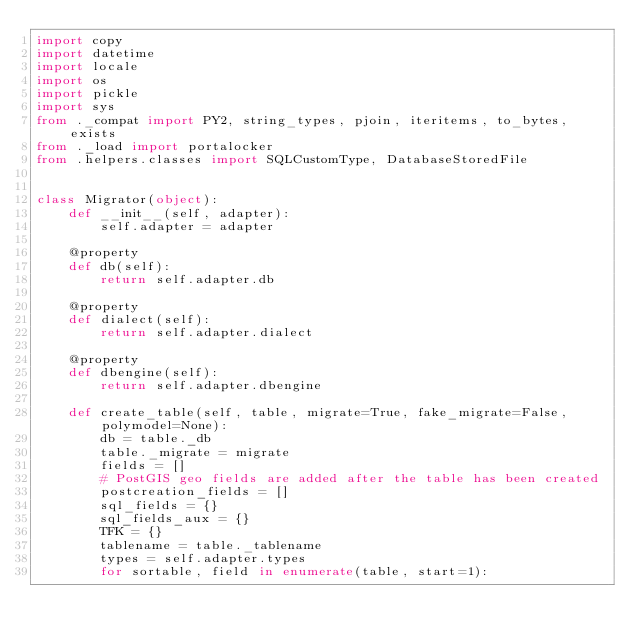<code> <loc_0><loc_0><loc_500><loc_500><_Python_>import copy
import datetime
import locale
import os
import pickle
import sys
from ._compat import PY2, string_types, pjoin, iteritems, to_bytes, exists
from ._load import portalocker
from .helpers.classes import SQLCustomType, DatabaseStoredFile


class Migrator(object):
    def __init__(self, adapter):
        self.adapter = adapter

    @property
    def db(self):
        return self.adapter.db

    @property
    def dialect(self):
        return self.adapter.dialect

    @property
    def dbengine(self):
        return self.adapter.dbengine

    def create_table(self, table, migrate=True, fake_migrate=False, polymodel=None):
        db = table._db
        table._migrate = migrate
        fields = []
        # PostGIS geo fields are added after the table has been created
        postcreation_fields = []
        sql_fields = {}
        sql_fields_aux = {}
        TFK = {}
        tablename = table._tablename
        types = self.adapter.types
        for sortable, field in enumerate(table, start=1):</code> 